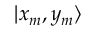Convert formula to latex. <formula><loc_0><loc_0><loc_500><loc_500>| x _ { m } , y _ { m } \rangle</formula> 